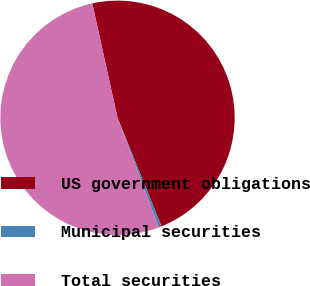Convert chart to OTSL. <chart><loc_0><loc_0><loc_500><loc_500><pie_chart><fcel>US government obligations<fcel>Municipal securities<fcel>Total securities<nl><fcel>47.34%<fcel>0.4%<fcel>52.26%<nl></chart> 